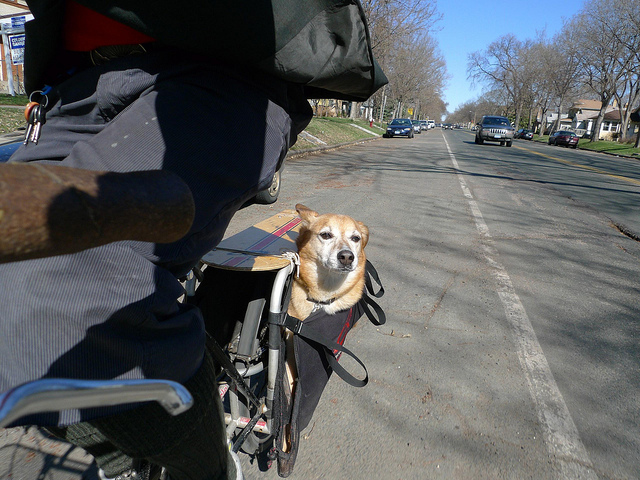What safety precautions should be taken when traveling with a dog like this? Safety precautions include securing the dog with harness straps to prevent it from jumping out or falling, ensuring the basket is well-attached to the bike, and possibly outfitting the dog with a helmet or goggles for eye protection. Additionally, one should avoid busy roads and check that the dog is comfortable and not stressed during the ride. 